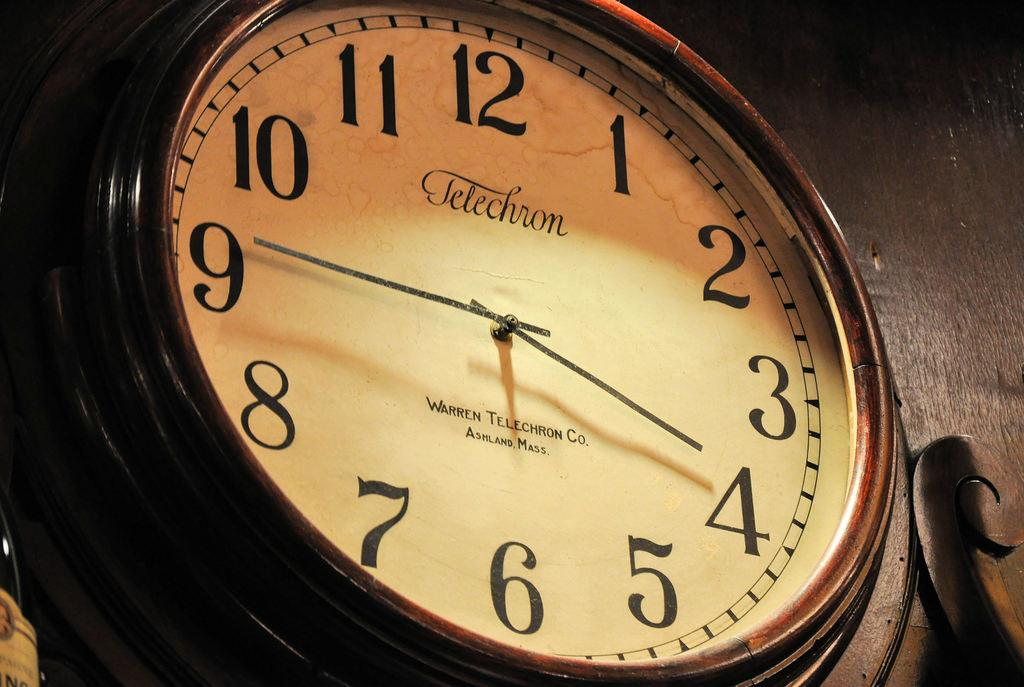<image>
Write a terse but informative summary of the picture. A round clock face that says Telechron on it. 